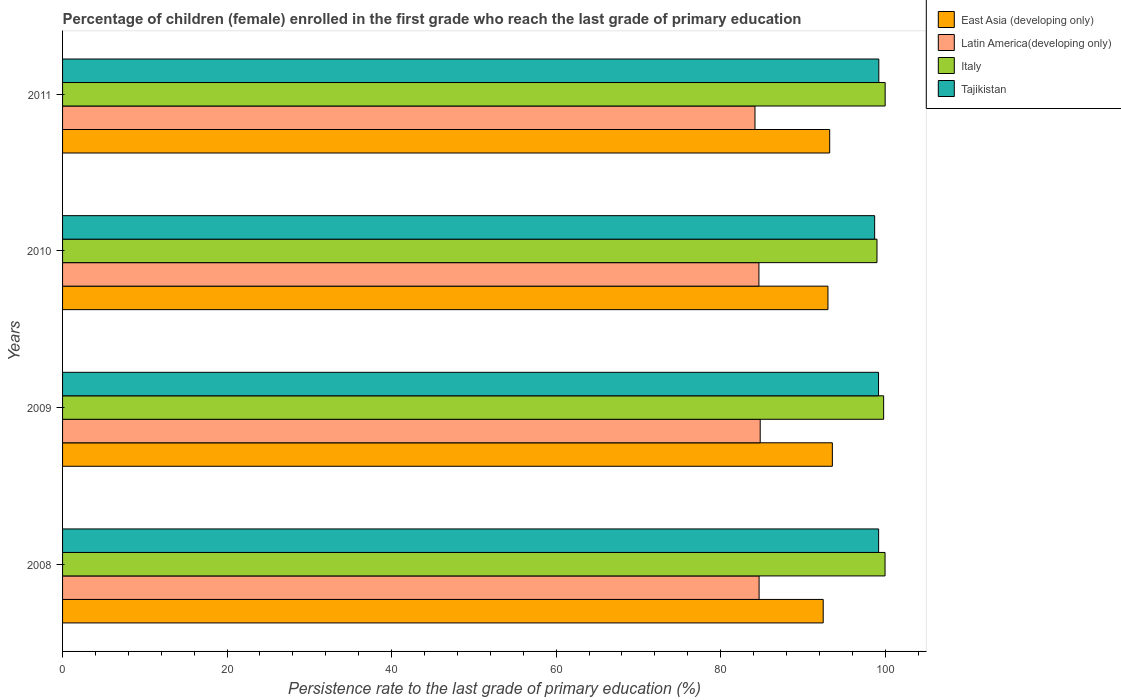How many different coloured bars are there?
Give a very brief answer. 4. Are the number of bars on each tick of the Y-axis equal?
Ensure brevity in your answer.  Yes. How many bars are there on the 4th tick from the top?
Keep it short and to the point. 4. What is the label of the 4th group of bars from the top?
Give a very brief answer. 2008. In how many cases, is the number of bars for a given year not equal to the number of legend labels?
Provide a succinct answer. 0. What is the persistence rate of children in Italy in 2011?
Offer a terse response. 100. Across all years, what is the maximum persistence rate of children in Latin America(developing only)?
Ensure brevity in your answer.  84.81. Across all years, what is the minimum persistence rate of children in Latin America(developing only)?
Provide a short and direct response. 84.17. What is the total persistence rate of children in Latin America(developing only) in the graph?
Make the answer very short. 338.31. What is the difference between the persistence rate of children in Tajikistan in 2008 and that in 2010?
Ensure brevity in your answer.  0.48. What is the difference between the persistence rate of children in East Asia (developing only) in 2009 and the persistence rate of children in Latin America(developing only) in 2011?
Your answer should be compact. 9.41. What is the average persistence rate of children in East Asia (developing only) per year?
Provide a succinct answer. 93.09. In the year 2008, what is the difference between the persistence rate of children in Italy and persistence rate of children in Tajikistan?
Provide a short and direct response. 0.78. What is the ratio of the persistence rate of children in East Asia (developing only) in 2009 to that in 2010?
Your answer should be compact. 1.01. Is the persistence rate of children in Tajikistan in 2008 less than that in 2009?
Offer a very short reply. No. What is the difference between the highest and the second highest persistence rate of children in Latin America(developing only)?
Provide a short and direct response. 0.14. What is the difference between the highest and the lowest persistence rate of children in Italy?
Keep it short and to the point. 0.99. Is the sum of the persistence rate of children in Latin America(developing only) in 2009 and 2010 greater than the maximum persistence rate of children in Tajikistan across all years?
Give a very brief answer. Yes. Is it the case that in every year, the sum of the persistence rate of children in Latin America(developing only) and persistence rate of children in Tajikistan is greater than the sum of persistence rate of children in East Asia (developing only) and persistence rate of children in Italy?
Offer a very short reply. No. What does the 3rd bar from the top in 2008 represents?
Offer a terse response. Latin America(developing only). What does the 4th bar from the bottom in 2009 represents?
Make the answer very short. Tajikistan. Is it the case that in every year, the sum of the persistence rate of children in Latin America(developing only) and persistence rate of children in East Asia (developing only) is greater than the persistence rate of children in Tajikistan?
Your answer should be very brief. Yes. How many bars are there?
Offer a terse response. 16. Are all the bars in the graph horizontal?
Your answer should be very brief. Yes. Are the values on the major ticks of X-axis written in scientific E-notation?
Keep it short and to the point. No. How are the legend labels stacked?
Offer a very short reply. Vertical. What is the title of the graph?
Your response must be concise. Percentage of children (female) enrolled in the first grade who reach the last grade of primary education. Does "OECD members" appear as one of the legend labels in the graph?
Your answer should be very brief. No. What is the label or title of the X-axis?
Give a very brief answer. Persistence rate to the last grade of primary education (%). What is the label or title of the Y-axis?
Your response must be concise. Years. What is the Persistence rate to the last grade of primary education (%) in East Asia (developing only) in 2008?
Make the answer very short. 92.47. What is the Persistence rate to the last grade of primary education (%) in Latin America(developing only) in 2008?
Your answer should be very brief. 84.67. What is the Persistence rate to the last grade of primary education (%) of Italy in 2008?
Ensure brevity in your answer.  99.99. What is the Persistence rate to the last grade of primary education (%) in Tajikistan in 2008?
Provide a succinct answer. 99.21. What is the Persistence rate to the last grade of primary education (%) in East Asia (developing only) in 2009?
Offer a terse response. 93.58. What is the Persistence rate to the last grade of primary education (%) in Latin America(developing only) in 2009?
Your response must be concise. 84.81. What is the Persistence rate to the last grade of primary education (%) in Italy in 2009?
Your answer should be very brief. 99.82. What is the Persistence rate to the last grade of primary education (%) of Tajikistan in 2009?
Provide a succinct answer. 99.19. What is the Persistence rate to the last grade of primary education (%) of East Asia (developing only) in 2010?
Ensure brevity in your answer.  93.05. What is the Persistence rate to the last grade of primary education (%) in Latin America(developing only) in 2010?
Your answer should be compact. 84.65. What is the Persistence rate to the last grade of primary education (%) of Italy in 2010?
Your answer should be compact. 99.01. What is the Persistence rate to the last grade of primary education (%) in Tajikistan in 2010?
Keep it short and to the point. 98.72. What is the Persistence rate to the last grade of primary education (%) of East Asia (developing only) in 2011?
Ensure brevity in your answer.  93.26. What is the Persistence rate to the last grade of primary education (%) of Latin America(developing only) in 2011?
Your response must be concise. 84.17. What is the Persistence rate to the last grade of primary education (%) in Italy in 2011?
Offer a very short reply. 100. What is the Persistence rate to the last grade of primary education (%) of Tajikistan in 2011?
Provide a succinct answer. 99.23. Across all years, what is the maximum Persistence rate to the last grade of primary education (%) of East Asia (developing only)?
Keep it short and to the point. 93.58. Across all years, what is the maximum Persistence rate to the last grade of primary education (%) of Latin America(developing only)?
Ensure brevity in your answer.  84.81. Across all years, what is the maximum Persistence rate to the last grade of primary education (%) in Italy?
Make the answer very short. 100. Across all years, what is the maximum Persistence rate to the last grade of primary education (%) in Tajikistan?
Make the answer very short. 99.23. Across all years, what is the minimum Persistence rate to the last grade of primary education (%) of East Asia (developing only)?
Give a very brief answer. 92.47. Across all years, what is the minimum Persistence rate to the last grade of primary education (%) of Latin America(developing only)?
Make the answer very short. 84.17. Across all years, what is the minimum Persistence rate to the last grade of primary education (%) in Italy?
Keep it short and to the point. 99.01. Across all years, what is the minimum Persistence rate to the last grade of primary education (%) of Tajikistan?
Your response must be concise. 98.72. What is the total Persistence rate to the last grade of primary education (%) of East Asia (developing only) in the graph?
Provide a short and direct response. 372.35. What is the total Persistence rate to the last grade of primary education (%) of Latin America(developing only) in the graph?
Your response must be concise. 338.31. What is the total Persistence rate to the last grade of primary education (%) in Italy in the graph?
Your answer should be very brief. 398.81. What is the total Persistence rate to the last grade of primary education (%) in Tajikistan in the graph?
Ensure brevity in your answer.  396.35. What is the difference between the Persistence rate to the last grade of primary education (%) of East Asia (developing only) in 2008 and that in 2009?
Offer a very short reply. -1.11. What is the difference between the Persistence rate to the last grade of primary education (%) in Latin America(developing only) in 2008 and that in 2009?
Give a very brief answer. -0.14. What is the difference between the Persistence rate to the last grade of primary education (%) of Italy in 2008 and that in 2009?
Your answer should be compact. 0.17. What is the difference between the Persistence rate to the last grade of primary education (%) in Tajikistan in 2008 and that in 2009?
Keep it short and to the point. 0.01. What is the difference between the Persistence rate to the last grade of primary education (%) of East Asia (developing only) in 2008 and that in 2010?
Your answer should be compact. -0.58. What is the difference between the Persistence rate to the last grade of primary education (%) in Latin America(developing only) in 2008 and that in 2010?
Your response must be concise. 0.02. What is the difference between the Persistence rate to the last grade of primary education (%) in Italy in 2008 and that in 2010?
Ensure brevity in your answer.  0.98. What is the difference between the Persistence rate to the last grade of primary education (%) in Tajikistan in 2008 and that in 2010?
Give a very brief answer. 0.48. What is the difference between the Persistence rate to the last grade of primary education (%) of East Asia (developing only) in 2008 and that in 2011?
Ensure brevity in your answer.  -0.79. What is the difference between the Persistence rate to the last grade of primary education (%) in Latin America(developing only) in 2008 and that in 2011?
Your answer should be compact. 0.5. What is the difference between the Persistence rate to the last grade of primary education (%) in Italy in 2008 and that in 2011?
Ensure brevity in your answer.  -0.01. What is the difference between the Persistence rate to the last grade of primary education (%) in Tajikistan in 2008 and that in 2011?
Provide a short and direct response. -0.02. What is the difference between the Persistence rate to the last grade of primary education (%) in East Asia (developing only) in 2009 and that in 2010?
Offer a very short reply. 0.54. What is the difference between the Persistence rate to the last grade of primary education (%) of Latin America(developing only) in 2009 and that in 2010?
Your answer should be compact. 0.16. What is the difference between the Persistence rate to the last grade of primary education (%) in Italy in 2009 and that in 2010?
Provide a succinct answer. 0.81. What is the difference between the Persistence rate to the last grade of primary education (%) in Tajikistan in 2009 and that in 2010?
Give a very brief answer. 0.47. What is the difference between the Persistence rate to the last grade of primary education (%) of East Asia (developing only) in 2009 and that in 2011?
Provide a short and direct response. 0.33. What is the difference between the Persistence rate to the last grade of primary education (%) in Latin America(developing only) in 2009 and that in 2011?
Give a very brief answer. 0.64. What is the difference between the Persistence rate to the last grade of primary education (%) of Italy in 2009 and that in 2011?
Your answer should be compact. -0.18. What is the difference between the Persistence rate to the last grade of primary education (%) of Tajikistan in 2009 and that in 2011?
Provide a short and direct response. -0.03. What is the difference between the Persistence rate to the last grade of primary education (%) of East Asia (developing only) in 2010 and that in 2011?
Provide a succinct answer. -0.21. What is the difference between the Persistence rate to the last grade of primary education (%) in Latin America(developing only) in 2010 and that in 2011?
Offer a very short reply. 0.48. What is the difference between the Persistence rate to the last grade of primary education (%) of Italy in 2010 and that in 2011?
Your answer should be very brief. -0.99. What is the difference between the Persistence rate to the last grade of primary education (%) of Tajikistan in 2010 and that in 2011?
Offer a terse response. -0.5. What is the difference between the Persistence rate to the last grade of primary education (%) of East Asia (developing only) in 2008 and the Persistence rate to the last grade of primary education (%) of Latin America(developing only) in 2009?
Provide a short and direct response. 7.66. What is the difference between the Persistence rate to the last grade of primary education (%) of East Asia (developing only) in 2008 and the Persistence rate to the last grade of primary education (%) of Italy in 2009?
Make the answer very short. -7.35. What is the difference between the Persistence rate to the last grade of primary education (%) in East Asia (developing only) in 2008 and the Persistence rate to the last grade of primary education (%) in Tajikistan in 2009?
Keep it short and to the point. -6.73. What is the difference between the Persistence rate to the last grade of primary education (%) of Latin America(developing only) in 2008 and the Persistence rate to the last grade of primary education (%) of Italy in 2009?
Make the answer very short. -15.14. What is the difference between the Persistence rate to the last grade of primary education (%) in Latin America(developing only) in 2008 and the Persistence rate to the last grade of primary education (%) in Tajikistan in 2009?
Offer a very short reply. -14.52. What is the difference between the Persistence rate to the last grade of primary education (%) of Italy in 2008 and the Persistence rate to the last grade of primary education (%) of Tajikistan in 2009?
Your response must be concise. 0.79. What is the difference between the Persistence rate to the last grade of primary education (%) in East Asia (developing only) in 2008 and the Persistence rate to the last grade of primary education (%) in Latin America(developing only) in 2010?
Give a very brief answer. 7.81. What is the difference between the Persistence rate to the last grade of primary education (%) in East Asia (developing only) in 2008 and the Persistence rate to the last grade of primary education (%) in Italy in 2010?
Ensure brevity in your answer.  -6.54. What is the difference between the Persistence rate to the last grade of primary education (%) of East Asia (developing only) in 2008 and the Persistence rate to the last grade of primary education (%) of Tajikistan in 2010?
Your response must be concise. -6.26. What is the difference between the Persistence rate to the last grade of primary education (%) of Latin America(developing only) in 2008 and the Persistence rate to the last grade of primary education (%) of Italy in 2010?
Your response must be concise. -14.33. What is the difference between the Persistence rate to the last grade of primary education (%) in Latin America(developing only) in 2008 and the Persistence rate to the last grade of primary education (%) in Tajikistan in 2010?
Offer a very short reply. -14.05. What is the difference between the Persistence rate to the last grade of primary education (%) of Italy in 2008 and the Persistence rate to the last grade of primary education (%) of Tajikistan in 2010?
Offer a very short reply. 1.26. What is the difference between the Persistence rate to the last grade of primary education (%) in East Asia (developing only) in 2008 and the Persistence rate to the last grade of primary education (%) in Latin America(developing only) in 2011?
Your answer should be very brief. 8.29. What is the difference between the Persistence rate to the last grade of primary education (%) of East Asia (developing only) in 2008 and the Persistence rate to the last grade of primary education (%) of Italy in 2011?
Your answer should be compact. -7.53. What is the difference between the Persistence rate to the last grade of primary education (%) of East Asia (developing only) in 2008 and the Persistence rate to the last grade of primary education (%) of Tajikistan in 2011?
Provide a succinct answer. -6.76. What is the difference between the Persistence rate to the last grade of primary education (%) of Latin America(developing only) in 2008 and the Persistence rate to the last grade of primary education (%) of Italy in 2011?
Keep it short and to the point. -15.33. What is the difference between the Persistence rate to the last grade of primary education (%) in Latin America(developing only) in 2008 and the Persistence rate to the last grade of primary education (%) in Tajikistan in 2011?
Your answer should be very brief. -14.55. What is the difference between the Persistence rate to the last grade of primary education (%) of Italy in 2008 and the Persistence rate to the last grade of primary education (%) of Tajikistan in 2011?
Give a very brief answer. 0.76. What is the difference between the Persistence rate to the last grade of primary education (%) in East Asia (developing only) in 2009 and the Persistence rate to the last grade of primary education (%) in Latin America(developing only) in 2010?
Your answer should be compact. 8.93. What is the difference between the Persistence rate to the last grade of primary education (%) of East Asia (developing only) in 2009 and the Persistence rate to the last grade of primary education (%) of Italy in 2010?
Ensure brevity in your answer.  -5.43. What is the difference between the Persistence rate to the last grade of primary education (%) of East Asia (developing only) in 2009 and the Persistence rate to the last grade of primary education (%) of Tajikistan in 2010?
Your answer should be very brief. -5.14. What is the difference between the Persistence rate to the last grade of primary education (%) in Latin America(developing only) in 2009 and the Persistence rate to the last grade of primary education (%) in Italy in 2010?
Your response must be concise. -14.2. What is the difference between the Persistence rate to the last grade of primary education (%) in Latin America(developing only) in 2009 and the Persistence rate to the last grade of primary education (%) in Tajikistan in 2010?
Offer a terse response. -13.91. What is the difference between the Persistence rate to the last grade of primary education (%) in Italy in 2009 and the Persistence rate to the last grade of primary education (%) in Tajikistan in 2010?
Your answer should be compact. 1.09. What is the difference between the Persistence rate to the last grade of primary education (%) of East Asia (developing only) in 2009 and the Persistence rate to the last grade of primary education (%) of Latin America(developing only) in 2011?
Make the answer very short. 9.41. What is the difference between the Persistence rate to the last grade of primary education (%) in East Asia (developing only) in 2009 and the Persistence rate to the last grade of primary education (%) in Italy in 2011?
Your answer should be very brief. -6.42. What is the difference between the Persistence rate to the last grade of primary education (%) in East Asia (developing only) in 2009 and the Persistence rate to the last grade of primary education (%) in Tajikistan in 2011?
Your response must be concise. -5.65. What is the difference between the Persistence rate to the last grade of primary education (%) in Latin America(developing only) in 2009 and the Persistence rate to the last grade of primary education (%) in Italy in 2011?
Offer a very short reply. -15.19. What is the difference between the Persistence rate to the last grade of primary education (%) of Latin America(developing only) in 2009 and the Persistence rate to the last grade of primary education (%) of Tajikistan in 2011?
Offer a terse response. -14.42. What is the difference between the Persistence rate to the last grade of primary education (%) of Italy in 2009 and the Persistence rate to the last grade of primary education (%) of Tajikistan in 2011?
Offer a very short reply. 0.59. What is the difference between the Persistence rate to the last grade of primary education (%) in East Asia (developing only) in 2010 and the Persistence rate to the last grade of primary education (%) in Latin America(developing only) in 2011?
Your answer should be very brief. 8.87. What is the difference between the Persistence rate to the last grade of primary education (%) of East Asia (developing only) in 2010 and the Persistence rate to the last grade of primary education (%) of Italy in 2011?
Provide a short and direct response. -6.95. What is the difference between the Persistence rate to the last grade of primary education (%) in East Asia (developing only) in 2010 and the Persistence rate to the last grade of primary education (%) in Tajikistan in 2011?
Give a very brief answer. -6.18. What is the difference between the Persistence rate to the last grade of primary education (%) of Latin America(developing only) in 2010 and the Persistence rate to the last grade of primary education (%) of Italy in 2011?
Make the answer very short. -15.35. What is the difference between the Persistence rate to the last grade of primary education (%) of Latin America(developing only) in 2010 and the Persistence rate to the last grade of primary education (%) of Tajikistan in 2011?
Your response must be concise. -14.57. What is the difference between the Persistence rate to the last grade of primary education (%) in Italy in 2010 and the Persistence rate to the last grade of primary education (%) in Tajikistan in 2011?
Your response must be concise. -0.22. What is the average Persistence rate to the last grade of primary education (%) of East Asia (developing only) per year?
Ensure brevity in your answer.  93.09. What is the average Persistence rate to the last grade of primary education (%) of Latin America(developing only) per year?
Provide a succinct answer. 84.58. What is the average Persistence rate to the last grade of primary education (%) in Italy per year?
Make the answer very short. 99.7. What is the average Persistence rate to the last grade of primary education (%) in Tajikistan per year?
Offer a very short reply. 99.09. In the year 2008, what is the difference between the Persistence rate to the last grade of primary education (%) in East Asia (developing only) and Persistence rate to the last grade of primary education (%) in Latin America(developing only)?
Your answer should be very brief. 7.79. In the year 2008, what is the difference between the Persistence rate to the last grade of primary education (%) in East Asia (developing only) and Persistence rate to the last grade of primary education (%) in Italy?
Provide a short and direct response. -7.52. In the year 2008, what is the difference between the Persistence rate to the last grade of primary education (%) in East Asia (developing only) and Persistence rate to the last grade of primary education (%) in Tajikistan?
Your answer should be very brief. -6.74. In the year 2008, what is the difference between the Persistence rate to the last grade of primary education (%) in Latin America(developing only) and Persistence rate to the last grade of primary education (%) in Italy?
Keep it short and to the point. -15.31. In the year 2008, what is the difference between the Persistence rate to the last grade of primary education (%) of Latin America(developing only) and Persistence rate to the last grade of primary education (%) of Tajikistan?
Your answer should be compact. -14.53. In the year 2008, what is the difference between the Persistence rate to the last grade of primary education (%) of Italy and Persistence rate to the last grade of primary education (%) of Tajikistan?
Provide a short and direct response. 0.78. In the year 2009, what is the difference between the Persistence rate to the last grade of primary education (%) in East Asia (developing only) and Persistence rate to the last grade of primary education (%) in Latin America(developing only)?
Offer a terse response. 8.77. In the year 2009, what is the difference between the Persistence rate to the last grade of primary education (%) of East Asia (developing only) and Persistence rate to the last grade of primary education (%) of Italy?
Offer a terse response. -6.24. In the year 2009, what is the difference between the Persistence rate to the last grade of primary education (%) in East Asia (developing only) and Persistence rate to the last grade of primary education (%) in Tajikistan?
Offer a very short reply. -5.61. In the year 2009, what is the difference between the Persistence rate to the last grade of primary education (%) of Latin America(developing only) and Persistence rate to the last grade of primary education (%) of Italy?
Ensure brevity in your answer.  -15.01. In the year 2009, what is the difference between the Persistence rate to the last grade of primary education (%) in Latin America(developing only) and Persistence rate to the last grade of primary education (%) in Tajikistan?
Your answer should be compact. -14.38. In the year 2009, what is the difference between the Persistence rate to the last grade of primary education (%) of Italy and Persistence rate to the last grade of primary education (%) of Tajikistan?
Make the answer very short. 0.62. In the year 2010, what is the difference between the Persistence rate to the last grade of primary education (%) in East Asia (developing only) and Persistence rate to the last grade of primary education (%) in Latin America(developing only)?
Give a very brief answer. 8.39. In the year 2010, what is the difference between the Persistence rate to the last grade of primary education (%) of East Asia (developing only) and Persistence rate to the last grade of primary education (%) of Italy?
Provide a short and direct response. -5.96. In the year 2010, what is the difference between the Persistence rate to the last grade of primary education (%) of East Asia (developing only) and Persistence rate to the last grade of primary education (%) of Tajikistan?
Your response must be concise. -5.68. In the year 2010, what is the difference between the Persistence rate to the last grade of primary education (%) in Latin America(developing only) and Persistence rate to the last grade of primary education (%) in Italy?
Offer a terse response. -14.35. In the year 2010, what is the difference between the Persistence rate to the last grade of primary education (%) of Latin America(developing only) and Persistence rate to the last grade of primary education (%) of Tajikistan?
Offer a terse response. -14.07. In the year 2010, what is the difference between the Persistence rate to the last grade of primary education (%) in Italy and Persistence rate to the last grade of primary education (%) in Tajikistan?
Ensure brevity in your answer.  0.28. In the year 2011, what is the difference between the Persistence rate to the last grade of primary education (%) in East Asia (developing only) and Persistence rate to the last grade of primary education (%) in Latin America(developing only)?
Ensure brevity in your answer.  9.08. In the year 2011, what is the difference between the Persistence rate to the last grade of primary education (%) of East Asia (developing only) and Persistence rate to the last grade of primary education (%) of Italy?
Ensure brevity in your answer.  -6.74. In the year 2011, what is the difference between the Persistence rate to the last grade of primary education (%) of East Asia (developing only) and Persistence rate to the last grade of primary education (%) of Tajikistan?
Make the answer very short. -5.97. In the year 2011, what is the difference between the Persistence rate to the last grade of primary education (%) of Latin America(developing only) and Persistence rate to the last grade of primary education (%) of Italy?
Your response must be concise. -15.83. In the year 2011, what is the difference between the Persistence rate to the last grade of primary education (%) in Latin America(developing only) and Persistence rate to the last grade of primary education (%) in Tajikistan?
Make the answer very short. -15.05. In the year 2011, what is the difference between the Persistence rate to the last grade of primary education (%) in Italy and Persistence rate to the last grade of primary education (%) in Tajikistan?
Your response must be concise. 0.77. What is the ratio of the Persistence rate to the last grade of primary education (%) in Latin America(developing only) in 2008 to that in 2009?
Keep it short and to the point. 1. What is the ratio of the Persistence rate to the last grade of primary education (%) in Italy in 2008 to that in 2009?
Provide a short and direct response. 1. What is the ratio of the Persistence rate to the last grade of primary education (%) in Italy in 2008 to that in 2010?
Ensure brevity in your answer.  1.01. What is the ratio of the Persistence rate to the last grade of primary education (%) of Tajikistan in 2008 to that in 2010?
Make the answer very short. 1. What is the ratio of the Persistence rate to the last grade of primary education (%) of East Asia (developing only) in 2008 to that in 2011?
Your answer should be very brief. 0.99. What is the ratio of the Persistence rate to the last grade of primary education (%) of Latin America(developing only) in 2008 to that in 2011?
Ensure brevity in your answer.  1.01. What is the ratio of the Persistence rate to the last grade of primary education (%) of Italy in 2008 to that in 2011?
Give a very brief answer. 1. What is the ratio of the Persistence rate to the last grade of primary education (%) in Tajikistan in 2008 to that in 2011?
Provide a succinct answer. 1. What is the ratio of the Persistence rate to the last grade of primary education (%) of Italy in 2009 to that in 2010?
Offer a terse response. 1.01. What is the ratio of the Persistence rate to the last grade of primary education (%) of Latin America(developing only) in 2009 to that in 2011?
Your response must be concise. 1.01. What is the ratio of the Persistence rate to the last grade of primary education (%) in Italy in 2009 to that in 2011?
Make the answer very short. 1. What is the ratio of the Persistence rate to the last grade of primary education (%) in Tajikistan in 2009 to that in 2011?
Keep it short and to the point. 1. What is the ratio of the Persistence rate to the last grade of primary education (%) in Latin America(developing only) in 2010 to that in 2011?
Offer a terse response. 1.01. What is the ratio of the Persistence rate to the last grade of primary education (%) of Italy in 2010 to that in 2011?
Give a very brief answer. 0.99. What is the difference between the highest and the second highest Persistence rate to the last grade of primary education (%) of East Asia (developing only)?
Your answer should be compact. 0.33. What is the difference between the highest and the second highest Persistence rate to the last grade of primary education (%) of Latin America(developing only)?
Ensure brevity in your answer.  0.14. What is the difference between the highest and the second highest Persistence rate to the last grade of primary education (%) in Italy?
Provide a short and direct response. 0.01. What is the difference between the highest and the second highest Persistence rate to the last grade of primary education (%) in Tajikistan?
Your response must be concise. 0.02. What is the difference between the highest and the lowest Persistence rate to the last grade of primary education (%) in East Asia (developing only)?
Ensure brevity in your answer.  1.11. What is the difference between the highest and the lowest Persistence rate to the last grade of primary education (%) of Latin America(developing only)?
Provide a succinct answer. 0.64. What is the difference between the highest and the lowest Persistence rate to the last grade of primary education (%) of Italy?
Offer a very short reply. 0.99. What is the difference between the highest and the lowest Persistence rate to the last grade of primary education (%) in Tajikistan?
Your response must be concise. 0.5. 